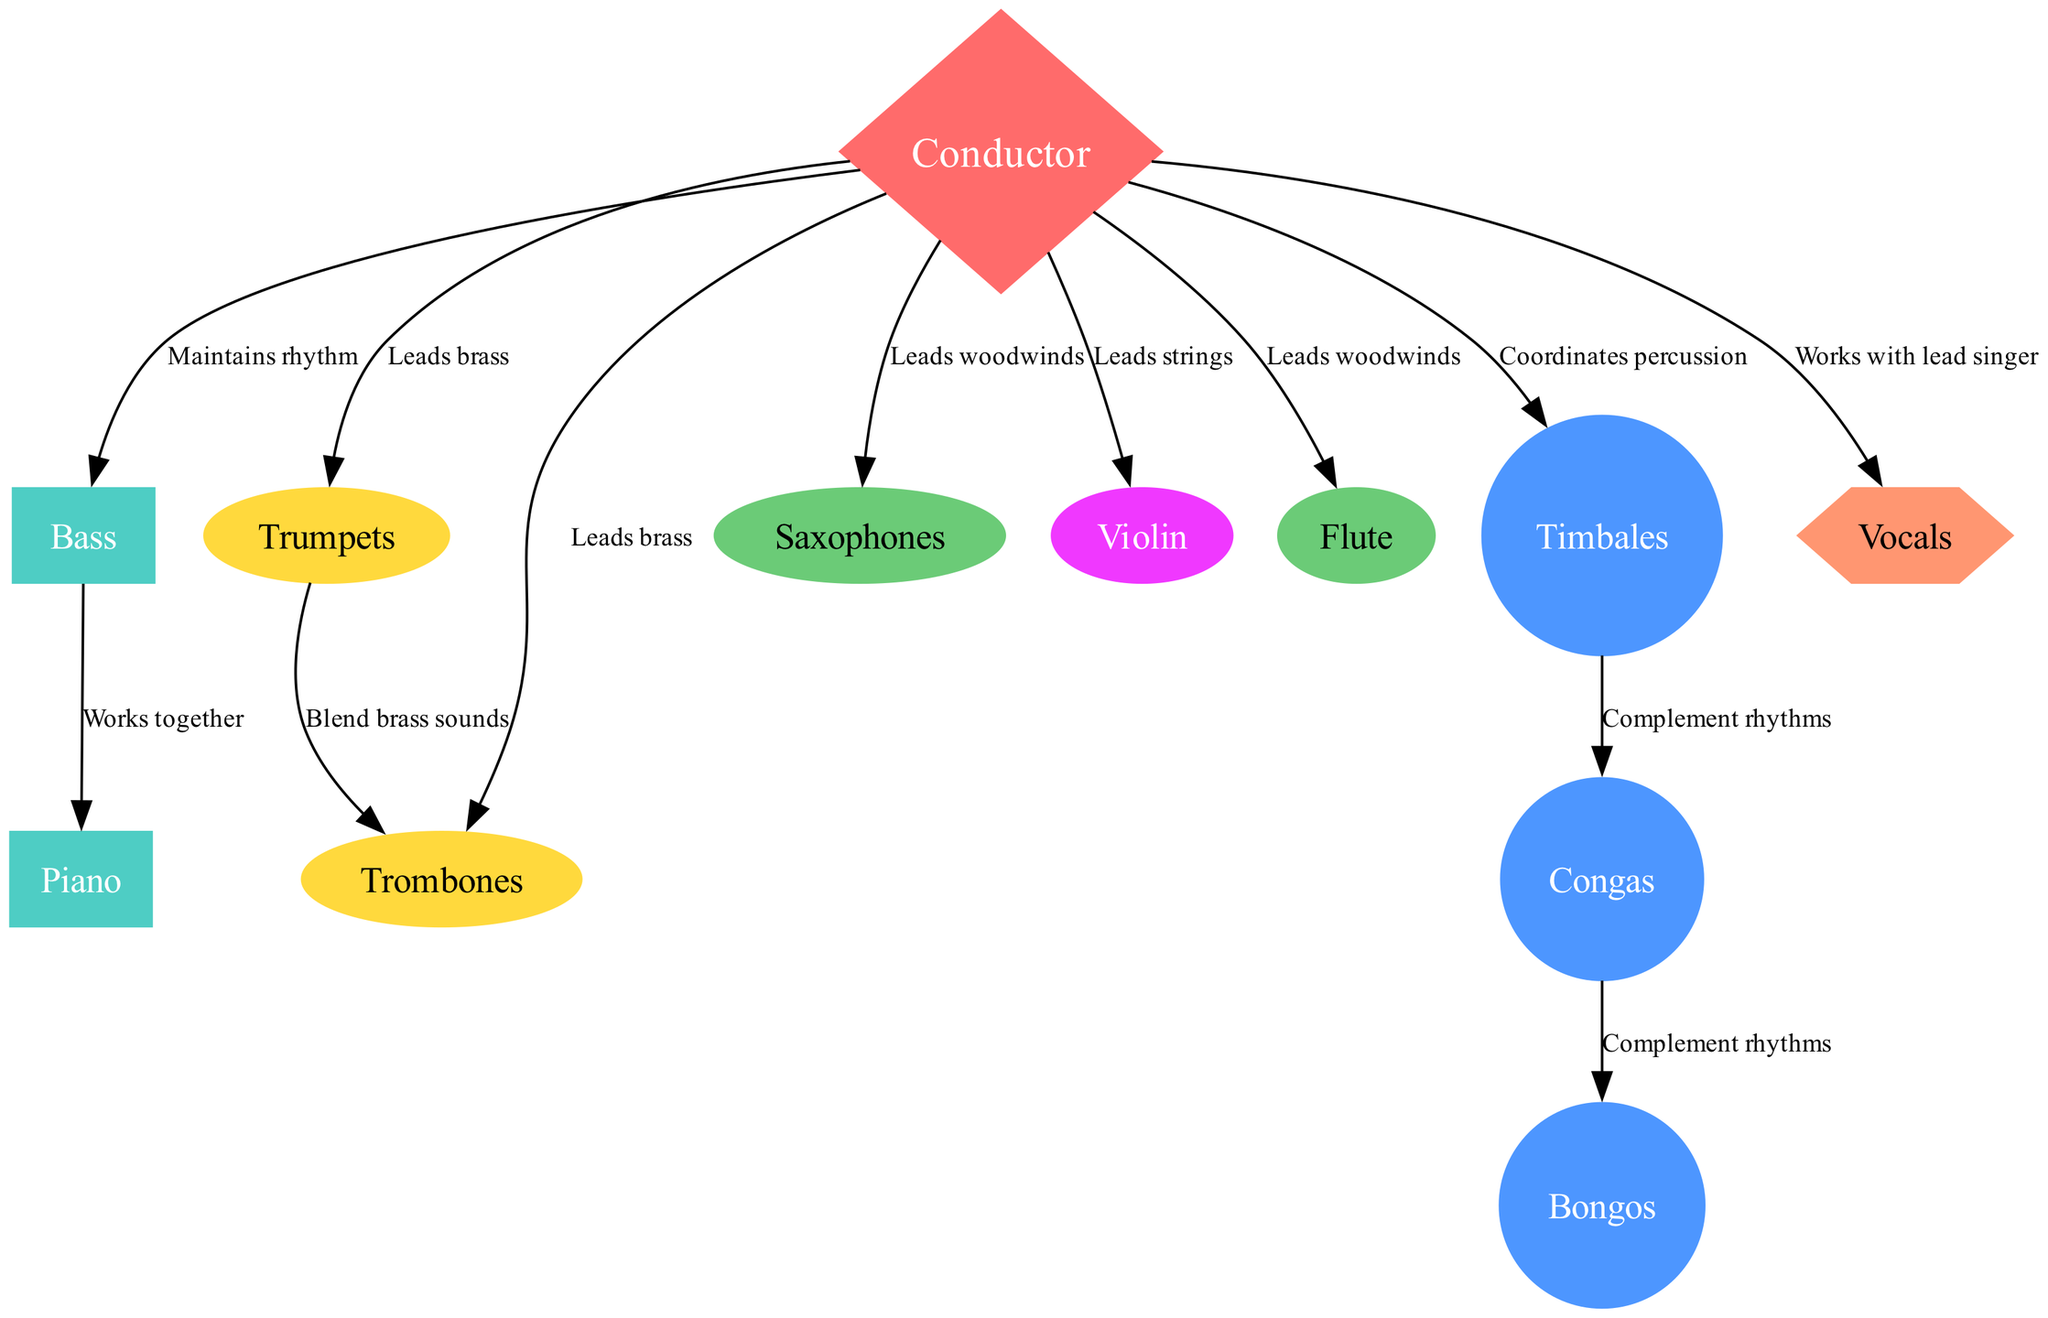What is the role of the conductor in the orchestra? The conductor is responsible for maintaining rhythm, leading the various sections including brass and woodwinds, coordinating percussion, and working with the lead singer.
Answer: Maintains rhythm, leads brass, leads woodwinds, coordinates percussion, works with lead singer How many percussion instruments are in the diagram? Examining the diagram, the percussion instruments listed are timbales, congas, and bongos, which gives us a total of three percussion instruments.
Answer: 3 Which instruments complement rhythms according to the diagram? The diagram shows that the congas and bongos complement each other, as well as the timbales and congas, indicating a cooperation between these instruments in contributing to the rhythm.
Answer: Congas, bongos, timbales How does the bass interact with the piano? The diagram indicates that the bass works together with the piano, implying a collaborative relationship between these two instruments.
Answer: Works together Which sections does the conductor lead? According to the edges originating from the conductor node to the other nodes, the conductor leads the brass (trumpets, trombones), woodwinds (saxophones, flute), and strings (violin).
Answer: Brass, woodwinds, strings What is the connection between trumpets and trombones? The diagram shows that trumpets blend brass sounds with trombones, indicating their relationship in the brass section of the orchestra.
Answer: Blend brass sounds What is the shape of the node representing the violins? The violin node in the diagram is represented as an ellipse, which distinguishes it from the other instruments that have different shapes.
Answer: Ellipse How many vocal nodes are present? The diagram includes one vocals node, which indicates that there is a single lead singer role in the traditional Cuban orchestra.
Answer: 1 What shape represents the conductor in the diagram? The conductor node is shaped like a diamond, which stands out compared to the other nodes that have different shapes.
Answer: Diamond 